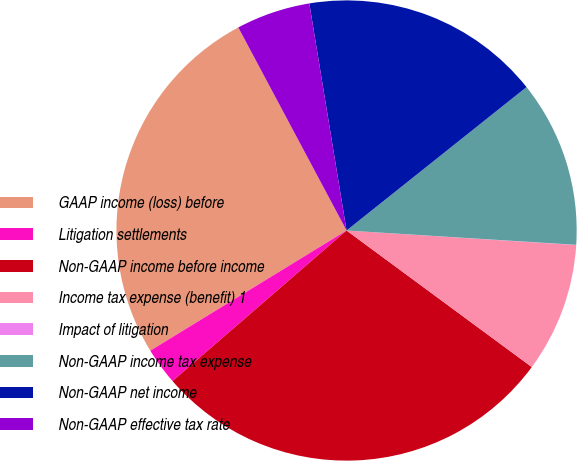<chart> <loc_0><loc_0><loc_500><loc_500><pie_chart><fcel>GAAP income (loss) before<fcel>Litigation settlements<fcel>Non-GAAP income before income<fcel>Income tax expense (benefit) 1<fcel>Impact of litigation<fcel>Non-GAAP income tax expense<fcel>Non-GAAP net income<fcel>Non-GAAP effective tax rate<nl><fcel>25.95%<fcel>2.61%<fcel>28.54%<fcel>9.1%<fcel>0.02%<fcel>11.7%<fcel>16.88%<fcel>5.21%<nl></chart> 